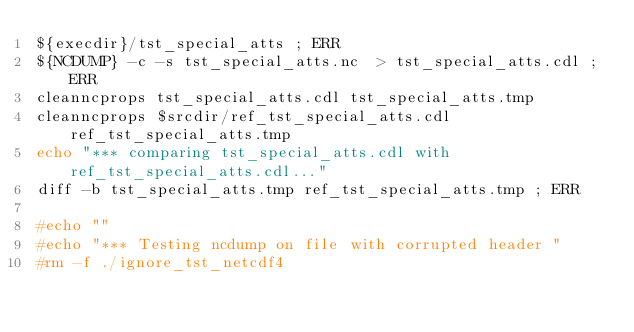<code> <loc_0><loc_0><loc_500><loc_500><_Bash_>${execdir}/tst_special_atts ; ERR
${NCDUMP} -c -s tst_special_atts.nc  > tst_special_atts.cdl ; ERR
cleanncprops tst_special_atts.cdl tst_special_atts.tmp
cleanncprops $srcdir/ref_tst_special_atts.cdl ref_tst_special_atts.tmp
echo "*** comparing tst_special_atts.cdl with ref_tst_special_atts.cdl..."
diff -b tst_special_atts.tmp ref_tst_special_atts.tmp ; ERR

#echo ""
#echo "*** Testing ncdump on file with corrupted header "
#rm -f ./ignore_tst_netcdf4</code> 